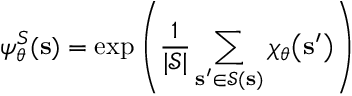<formula> <loc_0><loc_0><loc_500><loc_500>\psi _ { \boldsymbol \theta } ^ { S } ( s ) = \exp \left ( \frac { 1 } { | \mathcal { S } | } \sum _ { s ^ { \prime } \in \mathcal { S } ( s ) } \chi _ { \boldsymbol \theta } \left ( s ^ { \prime } \right ) \right )</formula> 